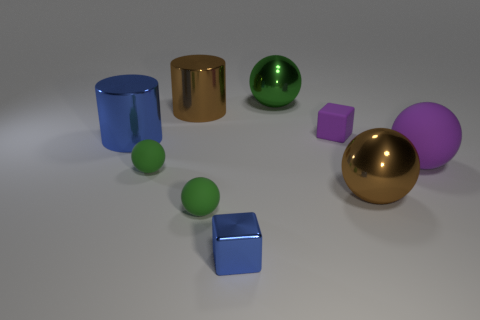Subtract all green spheres. How many were subtracted if there are1green spheres left? 2 Subtract all big brown metal spheres. How many spheres are left? 4 Subtract all brown cylinders. How many green balls are left? 3 Subtract all brown balls. How many balls are left? 4 Subtract all cubes. How many objects are left? 7 Subtract all brown balls. Subtract all brown cylinders. How many balls are left? 4 Subtract all tiny green cylinders. Subtract all blue blocks. How many objects are left? 8 Add 3 large metal objects. How many large metal objects are left? 7 Add 7 green objects. How many green objects exist? 10 Subtract 0 yellow spheres. How many objects are left? 9 